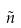Convert formula to latex. <formula><loc_0><loc_0><loc_500><loc_500>\tilde { n }</formula> 